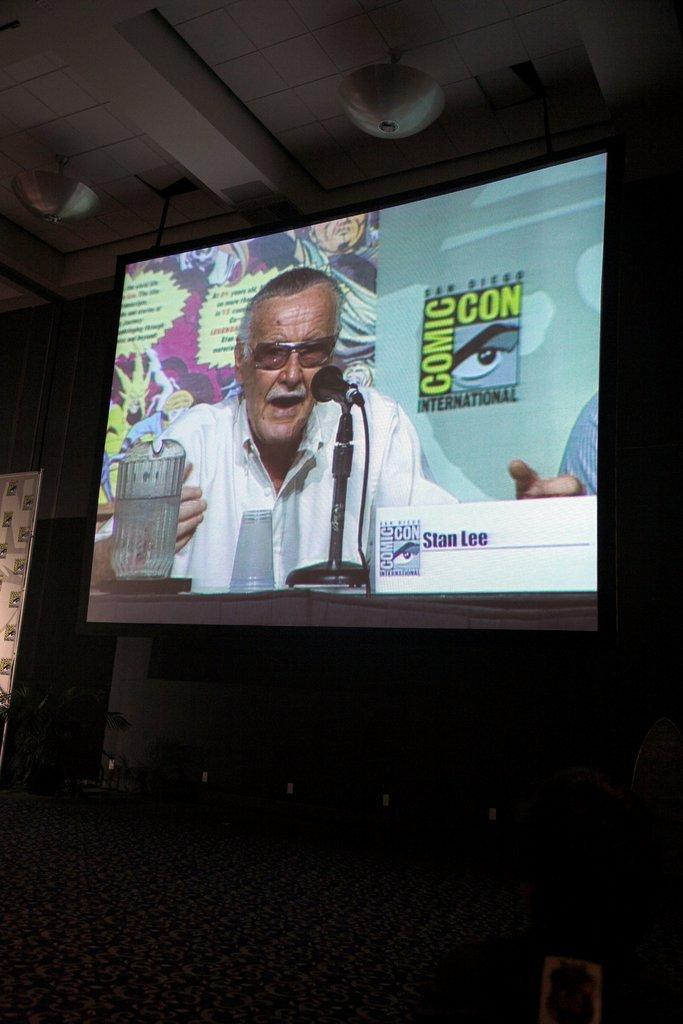<image>
Summarize the visual content of the image. A large TV displayed on a wall showing an advertisement for Comic Con. 